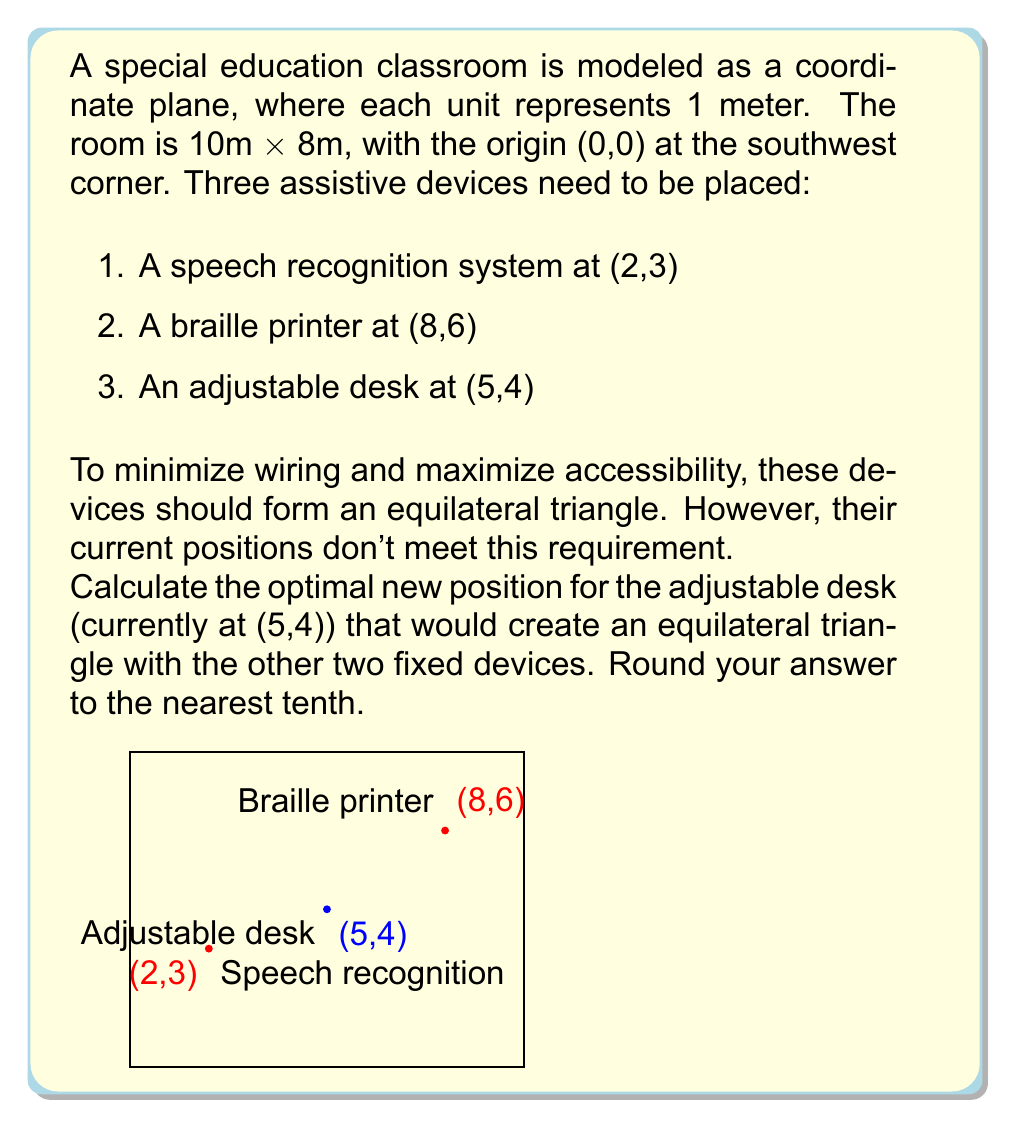Could you help me with this problem? Let's approach this step-by-step:

1) First, we need to calculate the distances between the fixed points:
   
   Distance between speech recognition and braille printer:
   $$d = \sqrt{(8-2)^2 + (6-3)^2} = \sqrt{36 + 9} = \sqrt{45} = 3\sqrt{5}$$

2) In an equilateral triangle, all sides are equal. So, the adjustable desk should be placed at a distance of $3\sqrt{5}$ from both fixed points.

3) The equation of a circle with center (x,y) and radius r is:
   $$(x-h)^2 + (y-k)^2 = r^2$$

   Where (h,k) is the center of the circle.

4) We need to find the intersection of two circles:
   Circle 1 (centered at speech recognition): $(x-2)^2 + (y-3)^2 = 45$
   Circle 2 (centered at braille printer): $(x-8)^2 + (y-6)^2 = 45$

5) Subtracting these equations eliminates the $x^2$ and $y^2$ terms:
   $(-4x+4) + (-6y+9) = (16x-64) + (12y-36)$
   $-20x-18y = -95$
   $10x+9y = 47.5$

6) Substitute this into one of the circle equations:
   $(x-2)^2 + (\frac{47.5-10x}{9}-3)^2 = 45$

7) Solving this equation (which can be done with a graphing calculator or computer algebra system) gives two solutions:
   $(x,y) \approx (5.8, 4.6)$ or $(x,y) \approx (2.0, 3.0)$

8) The second solution is the original position of the speech recognition system, so we discard it.

9) Rounding to the nearest tenth, our solution is (5.8, 4.6).
Answer: (5.8, 4.6) 